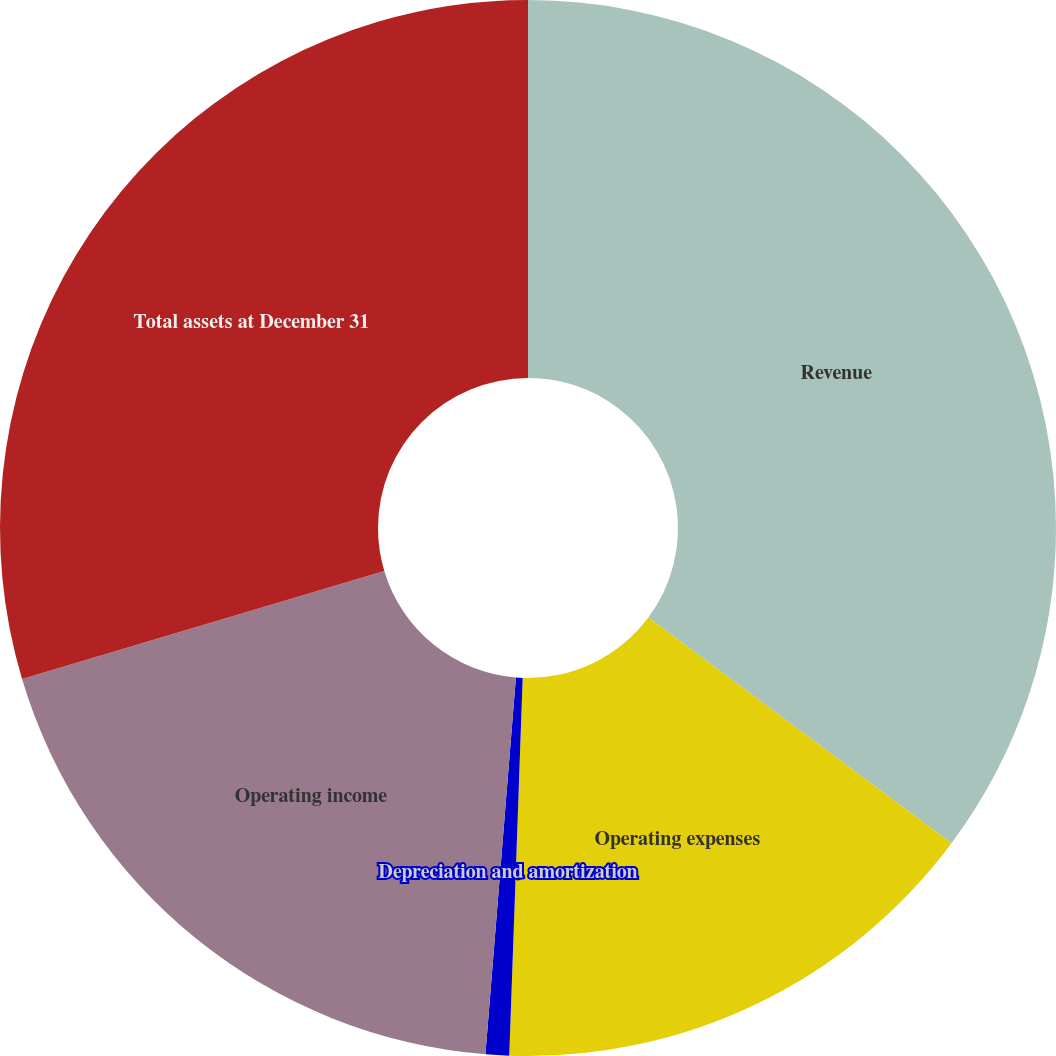Convert chart. <chart><loc_0><loc_0><loc_500><loc_500><pie_chart><fcel>Revenue<fcel>Operating expenses<fcel>Depreciation and amortization<fcel>Operating income<fcel>Total assets at December 31<nl><fcel>35.19%<fcel>15.38%<fcel>0.72%<fcel>19.1%<fcel>29.62%<nl></chart> 